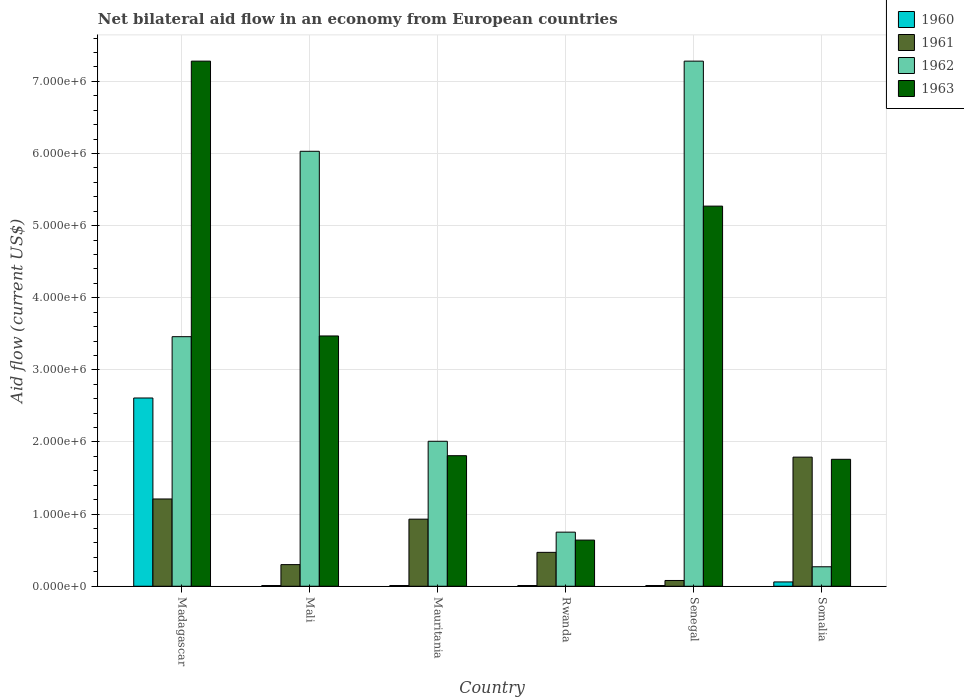How many different coloured bars are there?
Your answer should be very brief. 4. How many groups of bars are there?
Ensure brevity in your answer.  6. Are the number of bars on each tick of the X-axis equal?
Give a very brief answer. Yes. What is the label of the 2nd group of bars from the left?
Provide a succinct answer. Mali. In how many cases, is the number of bars for a given country not equal to the number of legend labels?
Your response must be concise. 0. What is the net bilateral aid flow in 1961 in Mauritania?
Your answer should be compact. 9.30e+05. Across all countries, what is the maximum net bilateral aid flow in 1961?
Ensure brevity in your answer.  1.79e+06. In which country was the net bilateral aid flow in 1963 maximum?
Give a very brief answer. Madagascar. In which country was the net bilateral aid flow in 1960 minimum?
Give a very brief answer. Mali. What is the total net bilateral aid flow in 1962 in the graph?
Make the answer very short. 1.98e+07. What is the difference between the net bilateral aid flow in 1961 in Senegal and that in Somalia?
Ensure brevity in your answer.  -1.71e+06. What is the difference between the net bilateral aid flow in 1960 in Madagascar and the net bilateral aid flow in 1962 in Rwanda?
Offer a very short reply. 1.86e+06. What is the average net bilateral aid flow in 1963 per country?
Your response must be concise. 3.37e+06. What is the difference between the net bilateral aid flow of/in 1962 and net bilateral aid flow of/in 1961 in Senegal?
Your response must be concise. 7.20e+06. What is the ratio of the net bilateral aid flow in 1963 in Senegal to that in Somalia?
Provide a short and direct response. 2.99. Is the net bilateral aid flow in 1962 in Madagascar less than that in Senegal?
Your answer should be compact. Yes. What is the difference between the highest and the second highest net bilateral aid flow in 1961?
Your answer should be very brief. 5.80e+05. What is the difference between the highest and the lowest net bilateral aid flow in 1961?
Your answer should be very brief. 1.71e+06. Is it the case that in every country, the sum of the net bilateral aid flow in 1963 and net bilateral aid flow in 1960 is greater than the sum of net bilateral aid flow in 1961 and net bilateral aid flow in 1962?
Ensure brevity in your answer.  Yes. What does the 3rd bar from the left in Senegal represents?
Offer a terse response. 1962. How many bars are there?
Your answer should be compact. 24. What is the difference between two consecutive major ticks on the Y-axis?
Your answer should be compact. 1.00e+06. Are the values on the major ticks of Y-axis written in scientific E-notation?
Offer a terse response. Yes. Does the graph contain any zero values?
Ensure brevity in your answer.  No. Does the graph contain grids?
Ensure brevity in your answer.  Yes. Where does the legend appear in the graph?
Ensure brevity in your answer.  Top right. How are the legend labels stacked?
Your response must be concise. Vertical. What is the title of the graph?
Offer a very short reply. Net bilateral aid flow in an economy from European countries. What is the label or title of the X-axis?
Your answer should be compact. Country. What is the Aid flow (current US$) in 1960 in Madagascar?
Keep it short and to the point. 2.61e+06. What is the Aid flow (current US$) in 1961 in Madagascar?
Offer a terse response. 1.21e+06. What is the Aid flow (current US$) of 1962 in Madagascar?
Ensure brevity in your answer.  3.46e+06. What is the Aid flow (current US$) in 1963 in Madagascar?
Provide a short and direct response. 7.28e+06. What is the Aid flow (current US$) in 1960 in Mali?
Offer a terse response. 10000. What is the Aid flow (current US$) of 1962 in Mali?
Keep it short and to the point. 6.03e+06. What is the Aid flow (current US$) of 1963 in Mali?
Provide a short and direct response. 3.47e+06. What is the Aid flow (current US$) of 1960 in Mauritania?
Your answer should be very brief. 10000. What is the Aid flow (current US$) in 1961 in Mauritania?
Your response must be concise. 9.30e+05. What is the Aid flow (current US$) of 1962 in Mauritania?
Provide a succinct answer. 2.01e+06. What is the Aid flow (current US$) in 1963 in Mauritania?
Keep it short and to the point. 1.81e+06. What is the Aid flow (current US$) of 1961 in Rwanda?
Provide a short and direct response. 4.70e+05. What is the Aid flow (current US$) in 1962 in Rwanda?
Your answer should be very brief. 7.50e+05. What is the Aid flow (current US$) of 1963 in Rwanda?
Ensure brevity in your answer.  6.40e+05. What is the Aid flow (current US$) in 1960 in Senegal?
Keep it short and to the point. 10000. What is the Aid flow (current US$) in 1961 in Senegal?
Your answer should be very brief. 8.00e+04. What is the Aid flow (current US$) of 1962 in Senegal?
Offer a terse response. 7.28e+06. What is the Aid flow (current US$) in 1963 in Senegal?
Your answer should be compact. 5.27e+06. What is the Aid flow (current US$) of 1960 in Somalia?
Provide a succinct answer. 6.00e+04. What is the Aid flow (current US$) in 1961 in Somalia?
Ensure brevity in your answer.  1.79e+06. What is the Aid flow (current US$) of 1963 in Somalia?
Offer a very short reply. 1.76e+06. Across all countries, what is the maximum Aid flow (current US$) in 1960?
Your response must be concise. 2.61e+06. Across all countries, what is the maximum Aid flow (current US$) in 1961?
Provide a short and direct response. 1.79e+06. Across all countries, what is the maximum Aid flow (current US$) in 1962?
Provide a succinct answer. 7.28e+06. Across all countries, what is the maximum Aid flow (current US$) in 1963?
Provide a succinct answer. 7.28e+06. Across all countries, what is the minimum Aid flow (current US$) of 1961?
Give a very brief answer. 8.00e+04. Across all countries, what is the minimum Aid flow (current US$) of 1962?
Provide a succinct answer. 2.70e+05. Across all countries, what is the minimum Aid flow (current US$) in 1963?
Give a very brief answer. 6.40e+05. What is the total Aid flow (current US$) of 1960 in the graph?
Your answer should be very brief. 2.71e+06. What is the total Aid flow (current US$) in 1961 in the graph?
Your response must be concise. 4.78e+06. What is the total Aid flow (current US$) of 1962 in the graph?
Your answer should be compact. 1.98e+07. What is the total Aid flow (current US$) in 1963 in the graph?
Give a very brief answer. 2.02e+07. What is the difference between the Aid flow (current US$) in 1960 in Madagascar and that in Mali?
Offer a very short reply. 2.60e+06. What is the difference between the Aid flow (current US$) of 1961 in Madagascar and that in Mali?
Keep it short and to the point. 9.10e+05. What is the difference between the Aid flow (current US$) of 1962 in Madagascar and that in Mali?
Provide a short and direct response. -2.57e+06. What is the difference between the Aid flow (current US$) in 1963 in Madagascar and that in Mali?
Give a very brief answer. 3.81e+06. What is the difference between the Aid flow (current US$) of 1960 in Madagascar and that in Mauritania?
Your answer should be very brief. 2.60e+06. What is the difference between the Aid flow (current US$) of 1962 in Madagascar and that in Mauritania?
Ensure brevity in your answer.  1.45e+06. What is the difference between the Aid flow (current US$) in 1963 in Madagascar and that in Mauritania?
Keep it short and to the point. 5.47e+06. What is the difference between the Aid flow (current US$) in 1960 in Madagascar and that in Rwanda?
Your answer should be compact. 2.60e+06. What is the difference between the Aid flow (current US$) of 1961 in Madagascar and that in Rwanda?
Offer a very short reply. 7.40e+05. What is the difference between the Aid flow (current US$) in 1962 in Madagascar and that in Rwanda?
Provide a short and direct response. 2.71e+06. What is the difference between the Aid flow (current US$) in 1963 in Madagascar and that in Rwanda?
Keep it short and to the point. 6.64e+06. What is the difference between the Aid flow (current US$) in 1960 in Madagascar and that in Senegal?
Offer a terse response. 2.60e+06. What is the difference between the Aid flow (current US$) of 1961 in Madagascar and that in Senegal?
Provide a succinct answer. 1.13e+06. What is the difference between the Aid flow (current US$) in 1962 in Madagascar and that in Senegal?
Offer a very short reply. -3.82e+06. What is the difference between the Aid flow (current US$) of 1963 in Madagascar and that in Senegal?
Keep it short and to the point. 2.01e+06. What is the difference between the Aid flow (current US$) in 1960 in Madagascar and that in Somalia?
Provide a succinct answer. 2.55e+06. What is the difference between the Aid flow (current US$) of 1961 in Madagascar and that in Somalia?
Your answer should be very brief. -5.80e+05. What is the difference between the Aid flow (current US$) in 1962 in Madagascar and that in Somalia?
Ensure brevity in your answer.  3.19e+06. What is the difference between the Aid flow (current US$) of 1963 in Madagascar and that in Somalia?
Make the answer very short. 5.52e+06. What is the difference between the Aid flow (current US$) in 1961 in Mali and that in Mauritania?
Offer a terse response. -6.30e+05. What is the difference between the Aid flow (current US$) of 1962 in Mali and that in Mauritania?
Keep it short and to the point. 4.02e+06. What is the difference between the Aid flow (current US$) in 1963 in Mali and that in Mauritania?
Ensure brevity in your answer.  1.66e+06. What is the difference between the Aid flow (current US$) in 1960 in Mali and that in Rwanda?
Ensure brevity in your answer.  0. What is the difference between the Aid flow (current US$) of 1962 in Mali and that in Rwanda?
Your response must be concise. 5.28e+06. What is the difference between the Aid flow (current US$) in 1963 in Mali and that in Rwanda?
Your answer should be compact. 2.83e+06. What is the difference between the Aid flow (current US$) of 1960 in Mali and that in Senegal?
Your answer should be very brief. 0. What is the difference between the Aid flow (current US$) in 1961 in Mali and that in Senegal?
Offer a very short reply. 2.20e+05. What is the difference between the Aid flow (current US$) of 1962 in Mali and that in Senegal?
Make the answer very short. -1.25e+06. What is the difference between the Aid flow (current US$) of 1963 in Mali and that in Senegal?
Make the answer very short. -1.80e+06. What is the difference between the Aid flow (current US$) of 1961 in Mali and that in Somalia?
Your answer should be very brief. -1.49e+06. What is the difference between the Aid flow (current US$) of 1962 in Mali and that in Somalia?
Ensure brevity in your answer.  5.76e+06. What is the difference between the Aid flow (current US$) of 1963 in Mali and that in Somalia?
Ensure brevity in your answer.  1.71e+06. What is the difference between the Aid flow (current US$) in 1960 in Mauritania and that in Rwanda?
Your answer should be very brief. 0. What is the difference between the Aid flow (current US$) of 1961 in Mauritania and that in Rwanda?
Offer a very short reply. 4.60e+05. What is the difference between the Aid flow (current US$) in 1962 in Mauritania and that in Rwanda?
Give a very brief answer. 1.26e+06. What is the difference between the Aid flow (current US$) of 1963 in Mauritania and that in Rwanda?
Offer a very short reply. 1.17e+06. What is the difference between the Aid flow (current US$) in 1961 in Mauritania and that in Senegal?
Your answer should be very brief. 8.50e+05. What is the difference between the Aid flow (current US$) in 1962 in Mauritania and that in Senegal?
Offer a very short reply. -5.27e+06. What is the difference between the Aid flow (current US$) of 1963 in Mauritania and that in Senegal?
Your answer should be compact. -3.46e+06. What is the difference between the Aid flow (current US$) of 1961 in Mauritania and that in Somalia?
Provide a succinct answer. -8.60e+05. What is the difference between the Aid flow (current US$) in 1962 in Mauritania and that in Somalia?
Give a very brief answer. 1.74e+06. What is the difference between the Aid flow (current US$) of 1963 in Mauritania and that in Somalia?
Provide a succinct answer. 5.00e+04. What is the difference between the Aid flow (current US$) in 1962 in Rwanda and that in Senegal?
Your answer should be compact. -6.53e+06. What is the difference between the Aid flow (current US$) of 1963 in Rwanda and that in Senegal?
Your response must be concise. -4.63e+06. What is the difference between the Aid flow (current US$) of 1960 in Rwanda and that in Somalia?
Provide a short and direct response. -5.00e+04. What is the difference between the Aid flow (current US$) in 1961 in Rwanda and that in Somalia?
Provide a short and direct response. -1.32e+06. What is the difference between the Aid flow (current US$) in 1963 in Rwanda and that in Somalia?
Give a very brief answer. -1.12e+06. What is the difference between the Aid flow (current US$) of 1960 in Senegal and that in Somalia?
Your answer should be very brief. -5.00e+04. What is the difference between the Aid flow (current US$) in 1961 in Senegal and that in Somalia?
Make the answer very short. -1.71e+06. What is the difference between the Aid flow (current US$) of 1962 in Senegal and that in Somalia?
Give a very brief answer. 7.01e+06. What is the difference between the Aid flow (current US$) in 1963 in Senegal and that in Somalia?
Offer a terse response. 3.51e+06. What is the difference between the Aid flow (current US$) of 1960 in Madagascar and the Aid flow (current US$) of 1961 in Mali?
Offer a terse response. 2.31e+06. What is the difference between the Aid flow (current US$) in 1960 in Madagascar and the Aid flow (current US$) in 1962 in Mali?
Provide a succinct answer. -3.42e+06. What is the difference between the Aid flow (current US$) of 1960 in Madagascar and the Aid flow (current US$) of 1963 in Mali?
Make the answer very short. -8.60e+05. What is the difference between the Aid flow (current US$) of 1961 in Madagascar and the Aid flow (current US$) of 1962 in Mali?
Give a very brief answer. -4.82e+06. What is the difference between the Aid flow (current US$) in 1961 in Madagascar and the Aid flow (current US$) in 1963 in Mali?
Your answer should be compact. -2.26e+06. What is the difference between the Aid flow (current US$) of 1960 in Madagascar and the Aid flow (current US$) of 1961 in Mauritania?
Provide a short and direct response. 1.68e+06. What is the difference between the Aid flow (current US$) in 1961 in Madagascar and the Aid flow (current US$) in 1962 in Mauritania?
Your answer should be very brief. -8.00e+05. What is the difference between the Aid flow (current US$) of 1961 in Madagascar and the Aid flow (current US$) of 1963 in Mauritania?
Your response must be concise. -6.00e+05. What is the difference between the Aid flow (current US$) of 1962 in Madagascar and the Aid flow (current US$) of 1963 in Mauritania?
Provide a short and direct response. 1.65e+06. What is the difference between the Aid flow (current US$) of 1960 in Madagascar and the Aid flow (current US$) of 1961 in Rwanda?
Provide a succinct answer. 2.14e+06. What is the difference between the Aid flow (current US$) of 1960 in Madagascar and the Aid flow (current US$) of 1962 in Rwanda?
Make the answer very short. 1.86e+06. What is the difference between the Aid flow (current US$) in 1960 in Madagascar and the Aid flow (current US$) in 1963 in Rwanda?
Provide a succinct answer. 1.97e+06. What is the difference between the Aid flow (current US$) of 1961 in Madagascar and the Aid flow (current US$) of 1963 in Rwanda?
Ensure brevity in your answer.  5.70e+05. What is the difference between the Aid flow (current US$) in 1962 in Madagascar and the Aid flow (current US$) in 1963 in Rwanda?
Your answer should be compact. 2.82e+06. What is the difference between the Aid flow (current US$) of 1960 in Madagascar and the Aid flow (current US$) of 1961 in Senegal?
Keep it short and to the point. 2.53e+06. What is the difference between the Aid flow (current US$) in 1960 in Madagascar and the Aid flow (current US$) in 1962 in Senegal?
Your response must be concise. -4.67e+06. What is the difference between the Aid flow (current US$) in 1960 in Madagascar and the Aid flow (current US$) in 1963 in Senegal?
Offer a terse response. -2.66e+06. What is the difference between the Aid flow (current US$) of 1961 in Madagascar and the Aid flow (current US$) of 1962 in Senegal?
Your answer should be compact. -6.07e+06. What is the difference between the Aid flow (current US$) of 1961 in Madagascar and the Aid flow (current US$) of 1963 in Senegal?
Keep it short and to the point. -4.06e+06. What is the difference between the Aid flow (current US$) of 1962 in Madagascar and the Aid flow (current US$) of 1963 in Senegal?
Make the answer very short. -1.81e+06. What is the difference between the Aid flow (current US$) of 1960 in Madagascar and the Aid flow (current US$) of 1961 in Somalia?
Provide a short and direct response. 8.20e+05. What is the difference between the Aid flow (current US$) of 1960 in Madagascar and the Aid flow (current US$) of 1962 in Somalia?
Provide a succinct answer. 2.34e+06. What is the difference between the Aid flow (current US$) of 1960 in Madagascar and the Aid flow (current US$) of 1963 in Somalia?
Your answer should be very brief. 8.50e+05. What is the difference between the Aid flow (current US$) in 1961 in Madagascar and the Aid flow (current US$) in 1962 in Somalia?
Make the answer very short. 9.40e+05. What is the difference between the Aid flow (current US$) of 1961 in Madagascar and the Aid flow (current US$) of 1963 in Somalia?
Offer a terse response. -5.50e+05. What is the difference between the Aid flow (current US$) in 1962 in Madagascar and the Aid flow (current US$) in 1963 in Somalia?
Your answer should be compact. 1.70e+06. What is the difference between the Aid flow (current US$) in 1960 in Mali and the Aid flow (current US$) in 1961 in Mauritania?
Your answer should be compact. -9.20e+05. What is the difference between the Aid flow (current US$) in 1960 in Mali and the Aid flow (current US$) in 1962 in Mauritania?
Offer a very short reply. -2.00e+06. What is the difference between the Aid flow (current US$) in 1960 in Mali and the Aid flow (current US$) in 1963 in Mauritania?
Provide a short and direct response. -1.80e+06. What is the difference between the Aid flow (current US$) of 1961 in Mali and the Aid flow (current US$) of 1962 in Mauritania?
Offer a very short reply. -1.71e+06. What is the difference between the Aid flow (current US$) of 1961 in Mali and the Aid flow (current US$) of 1963 in Mauritania?
Give a very brief answer. -1.51e+06. What is the difference between the Aid flow (current US$) in 1962 in Mali and the Aid flow (current US$) in 1963 in Mauritania?
Offer a very short reply. 4.22e+06. What is the difference between the Aid flow (current US$) of 1960 in Mali and the Aid flow (current US$) of 1961 in Rwanda?
Offer a terse response. -4.60e+05. What is the difference between the Aid flow (current US$) of 1960 in Mali and the Aid flow (current US$) of 1962 in Rwanda?
Provide a short and direct response. -7.40e+05. What is the difference between the Aid flow (current US$) in 1960 in Mali and the Aid flow (current US$) in 1963 in Rwanda?
Keep it short and to the point. -6.30e+05. What is the difference between the Aid flow (current US$) in 1961 in Mali and the Aid flow (current US$) in 1962 in Rwanda?
Make the answer very short. -4.50e+05. What is the difference between the Aid flow (current US$) of 1961 in Mali and the Aid flow (current US$) of 1963 in Rwanda?
Offer a very short reply. -3.40e+05. What is the difference between the Aid flow (current US$) of 1962 in Mali and the Aid flow (current US$) of 1963 in Rwanda?
Offer a terse response. 5.39e+06. What is the difference between the Aid flow (current US$) in 1960 in Mali and the Aid flow (current US$) in 1962 in Senegal?
Ensure brevity in your answer.  -7.27e+06. What is the difference between the Aid flow (current US$) of 1960 in Mali and the Aid flow (current US$) of 1963 in Senegal?
Your answer should be compact. -5.26e+06. What is the difference between the Aid flow (current US$) in 1961 in Mali and the Aid flow (current US$) in 1962 in Senegal?
Give a very brief answer. -6.98e+06. What is the difference between the Aid flow (current US$) of 1961 in Mali and the Aid flow (current US$) of 1963 in Senegal?
Offer a terse response. -4.97e+06. What is the difference between the Aid flow (current US$) of 1962 in Mali and the Aid flow (current US$) of 1963 in Senegal?
Provide a succinct answer. 7.60e+05. What is the difference between the Aid flow (current US$) of 1960 in Mali and the Aid flow (current US$) of 1961 in Somalia?
Provide a short and direct response. -1.78e+06. What is the difference between the Aid flow (current US$) of 1960 in Mali and the Aid flow (current US$) of 1962 in Somalia?
Your answer should be compact. -2.60e+05. What is the difference between the Aid flow (current US$) of 1960 in Mali and the Aid flow (current US$) of 1963 in Somalia?
Offer a very short reply. -1.75e+06. What is the difference between the Aid flow (current US$) in 1961 in Mali and the Aid flow (current US$) in 1963 in Somalia?
Provide a short and direct response. -1.46e+06. What is the difference between the Aid flow (current US$) in 1962 in Mali and the Aid flow (current US$) in 1963 in Somalia?
Provide a short and direct response. 4.27e+06. What is the difference between the Aid flow (current US$) in 1960 in Mauritania and the Aid flow (current US$) in 1961 in Rwanda?
Your answer should be very brief. -4.60e+05. What is the difference between the Aid flow (current US$) of 1960 in Mauritania and the Aid flow (current US$) of 1962 in Rwanda?
Give a very brief answer. -7.40e+05. What is the difference between the Aid flow (current US$) in 1960 in Mauritania and the Aid flow (current US$) in 1963 in Rwanda?
Your response must be concise. -6.30e+05. What is the difference between the Aid flow (current US$) of 1962 in Mauritania and the Aid flow (current US$) of 1963 in Rwanda?
Offer a terse response. 1.37e+06. What is the difference between the Aid flow (current US$) of 1960 in Mauritania and the Aid flow (current US$) of 1962 in Senegal?
Your answer should be very brief. -7.27e+06. What is the difference between the Aid flow (current US$) in 1960 in Mauritania and the Aid flow (current US$) in 1963 in Senegal?
Provide a short and direct response. -5.26e+06. What is the difference between the Aid flow (current US$) of 1961 in Mauritania and the Aid flow (current US$) of 1962 in Senegal?
Make the answer very short. -6.35e+06. What is the difference between the Aid flow (current US$) of 1961 in Mauritania and the Aid flow (current US$) of 1963 in Senegal?
Your answer should be compact. -4.34e+06. What is the difference between the Aid flow (current US$) in 1962 in Mauritania and the Aid flow (current US$) in 1963 in Senegal?
Offer a very short reply. -3.26e+06. What is the difference between the Aid flow (current US$) of 1960 in Mauritania and the Aid flow (current US$) of 1961 in Somalia?
Your response must be concise. -1.78e+06. What is the difference between the Aid flow (current US$) in 1960 in Mauritania and the Aid flow (current US$) in 1963 in Somalia?
Keep it short and to the point. -1.75e+06. What is the difference between the Aid flow (current US$) in 1961 in Mauritania and the Aid flow (current US$) in 1962 in Somalia?
Offer a terse response. 6.60e+05. What is the difference between the Aid flow (current US$) in 1961 in Mauritania and the Aid flow (current US$) in 1963 in Somalia?
Offer a very short reply. -8.30e+05. What is the difference between the Aid flow (current US$) of 1960 in Rwanda and the Aid flow (current US$) of 1961 in Senegal?
Offer a very short reply. -7.00e+04. What is the difference between the Aid flow (current US$) of 1960 in Rwanda and the Aid flow (current US$) of 1962 in Senegal?
Your answer should be very brief. -7.27e+06. What is the difference between the Aid flow (current US$) of 1960 in Rwanda and the Aid flow (current US$) of 1963 in Senegal?
Give a very brief answer. -5.26e+06. What is the difference between the Aid flow (current US$) in 1961 in Rwanda and the Aid flow (current US$) in 1962 in Senegal?
Ensure brevity in your answer.  -6.81e+06. What is the difference between the Aid flow (current US$) in 1961 in Rwanda and the Aid flow (current US$) in 1963 in Senegal?
Your response must be concise. -4.80e+06. What is the difference between the Aid flow (current US$) in 1962 in Rwanda and the Aid flow (current US$) in 1963 in Senegal?
Provide a succinct answer. -4.52e+06. What is the difference between the Aid flow (current US$) of 1960 in Rwanda and the Aid flow (current US$) of 1961 in Somalia?
Offer a very short reply. -1.78e+06. What is the difference between the Aid flow (current US$) in 1960 in Rwanda and the Aid flow (current US$) in 1962 in Somalia?
Offer a terse response. -2.60e+05. What is the difference between the Aid flow (current US$) in 1960 in Rwanda and the Aid flow (current US$) in 1963 in Somalia?
Your response must be concise. -1.75e+06. What is the difference between the Aid flow (current US$) of 1961 in Rwanda and the Aid flow (current US$) of 1963 in Somalia?
Keep it short and to the point. -1.29e+06. What is the difference between the Aid flow (current US$) in 1962 in Rwanda and the Aid flow (current US$) in 1963 in Somalia?
Offer a terse response. -1.01e+06. What is the difference between the Aid flow (current US$) of 1960 in Senegal and the Aid flow (current US$) of 1961 in Somalia?
Keep it short and to the point. -1.78e+06. What is the difference between the Aid flow (current US$) of 1960 in Senegal and the Aid flow (current US$) of 1962 in Somalia?
Your answer should be compact. -2.60e+05. What is the difference between the Aid flow (current US$) of 1960 in Senegal and the Aid flow (current US$) of 1963 in Somalia?
Make the answer very short. -1.75e+06. What is the difference between the Aid flow (current US$) in 1961 in Senegal and the Aid flow (current US$) in 1962 in Somalia?
Make the answer very short. -1.90e+05. What is the difference between the Aid flow (current US$) of 1961 in Senegal and the Aid flow (current US$) of 1963 in Somalia?
Make the answer very short. -1.68e+06. What is the difference between the Aid flow (current US$) in 1962 in Senegal and the Aid flow (current US$) in 1963 in Somalia?
Make the answer very short. 5.52e+06. What is the average Aid flow (current US$) in 1960 per country?
Offer a very short reply. 4.52e+05. What is the average Aid flow (current US$) of 1961 per country?
Your answer should be very brief. 7.97e+05. What is the average Aid flow (current US$) of 1962 per country?
Your answer should be very brief. 3.30e+06. What is the average Aid flow (current US$) of 1963 per country?
Keep it short and to the point. 3.37e+06. What is the difference between the Aid flow (current US$) of 1960 and Aid flow (current US$) of 1961 in Madagascar?
Make the answer very short. 1.40e+06. What is the difference between the Aid flow (current US$) in 1960 and Aid flow (current US$) in 1962 in Madagascar?
Provide a short and direct response. -8.50e+05. What is the difference between the Aid flow (current US$) of 1960 and Aid flow (current US$) of 1963 in Madagascar?
Provide a short and direct response. -4.67e+06. What is the difference between the Aid flow (current US$) of 1961 and Aid flow (current US$) of 1962 in Madagascar?
Provide a succinct answer. -2.25e+06. What is the difference between the Aid flow (current US$) of 1961 and Aid flow (current US$) of 1963 in Madagascar?
Keep it short and to the point. -6.07e+06. What is the difference between the Aid flow (current US$) of 1962 and Aid flow (current US$) of 1963 in Madagascar?
Provide a short and direct response. -3.82e+06. What is the difference between the Aid flow (current US$) of 1960 and Aid flow (current US$) of 1961 in Mali?
Offer a very short reply. -2.90e+05. What is the difference between the Aid flow (current US$) in 1960 and Aid flow (current US$) in 1962 in Mali?
Offer a very short reply. -6.02e+06. What is the difference between the Aid flow (current US$) of 1960 and Aid flow (current US$) of 1963 in Mali?
Give a very brief answer. -3.46e+06. What is the difference between the Aid flow (current US$) in 1961 and Aid flow (current US$) in 1962 in Mali?
Provide a short and direct response. -5.73e+06. What is the difference between the Aid flow (current US$) of 1961 and Aid flow (current US$) of 1963 in Mali?
Your answer should be compact. -3.17e+06. What is the difference between the Aid flow (current US$) of 1962 and Aid flow (current US$) of 1963 in Mali?
Your answer should be compact. 2.56e+06. What is the difference between the Aid flow (current US$) of 1960 and Aid flow (current US$) of 1961 in Mauritania?
Offer a terse response. -9.20e+05. What is the difference between the Aid flow (current US$) in 1960 and Aid flow (current US$) in 1963 in Mauritania?
Provide a short and direct response. -1.80e+06. What is the difference between the Aid flow (current US$) of 1961 and Aid flow (current US$) of 1962 in Mauritania?
Ensure brevity in your answer.  -1.08e+06. What is the difference between the Aid flow (current US$) of 1961 and Aid flow (current US$) of 1963 in Mauritania?
Provide a short and direct response. -8.80e+05. What is the difference between the Aid flow (current US$) of 1960 and Aid flow (current US$) of 1961 in Rwanda?
Offer a very short reply. -4.60e+05. What is the difference between the Aid flow (current US$) in 1960 and Aid flow (current US$) in 1962 in Rwanda?
Make the answer very short. -7.40e+05. What is the difference between the Aid flow (current US$) in 1960 and Aid flow (current US$) in 1963 in Rwanda?
Your response must be concise. -6.30e+05. What is the difference between the Aid flow (current US$) of 1961 and Aid flow (current US$) of 1962 in Rwanda?
Your response must be concise. -2.80e+05. What is the difference between the Aid flow (current US$) in 1962 and Aid flow (current US$) in 1963 in Rwanda?
Ensure brevity in your answer.  1.10e+05. What is the difference between the Aid flow (current US$) in 1960 and Aid flow (current US$) in 1961 in Senegal?
Offer a terse response. -7.00e+04. What is the difference between the Aid flow (current US$) in 1960 and Aid flow (current US$) in 1962 in Senegal?
Your response must be concise. -7.27e+06. What is the difference between the Aid flow (current US$) of 1960 and Aid flow (current US$) of 1963 in Senegal?
Give a very brief answer. -5.26e+06. What is the difference between the Aid flow (current US$) of 1961 and Aid flow (current US$) of 1962 in Senegal?
Your response must be concise. -7.20e+06. What is the difference between the Aid flow (current US$) of 1961 and Aid flow (current US$) of 1963 in Senegal?
Your response must be concise. -5.19e+06. What is the difference between the Aid flow (current US$) in 1962 and Aid flow (current US$) in 1963 in Senegal?
Keep it short and to the point. 2.01e+06. What is the difference between the Aid flow (current US$) of 1960 and Aid flow (current US$) of 1961 in Somalia?
Provide a short and direct response. -1.73e+06. What is the difference between the Aid flow (current US$) in 1960 and Aid flow (current US$) in 1963 in Somalia?
Provide a short and direct response. -1.70e+06. What is the difference between the Aid flow (current US$) in 1961 and Aid flow (current US$) in 1962 in Somalia?
Make the answer very short. 1.52e+06. What is the difference between the Aid flow (current US$) in 1961 and Aid flow (current US$) in 1963 in Somalia?
Keep it short and to the point. 3.00e+04. What is the difference between the Aid flow (current US$) in 1962 and Aid flow (current US$) in 1963 in Somalia?
Provide a succinct answer. -1.49e+06. What is the ratio of the Aid flow (current US$) in 1960 in Madagascar to that in Mali?
Offer a very short reply. 261. What is the ratio of the Aid flow (current US$) of 1961 in Madagascar to that in Mali?
Offer a terse response. 4.03. What is the ratio of the Aid flow (current US$) in 1962 in Madagascar to that in Mali?
Make the answer very short. 0.57. What is the ratio of the Aid flow (current US$) in 1963 in Madagascar to that in Mali?
Your answer should be very brief. 2.1. What is the ratio of the Aid flow (current US$) in 1960 in Madagascar to that in Mauritania?
Give a very brief answer. 261. What is the ratio of the Aid flow (current US$) in 1961 in Madagascar to that in Mauritania?
Make the answer very short. 1.3. What is the ratio of the Aid flow (current US$) in 1962 in Madagascar to that in Mauritania?
Provide a succinct answer. 1.72. What is the ratio of the Aid flow (current US$) of 1963 in Madagascar to that in Mauritania?
Keep it short and to the point. 4.02. What is the ratio of the Aid flow (current US$) in 1960 in Madagascar to that in Rwanda?
Make the answer very short. 261. What is the ratio of the Aid flow (current US$) of 1961 in Madagascar to that in Rwanda?
Keep it short and to the point. 2.57. What is the ratio of the Aid flow (current US$) of 1962 in Madagascar to that in Rwanda?
Make the answer very short. 4.61. What is the ratio of the Aid flow (current US$) in 1963 in Madagascar to that in Rwanda?
Provide a succinct answer. 11.38. What is the ratio of the Aid flow (current US$) in 1960 in Madagascar to that in Senegal?
Offer a very short reply. 261. What is the ratio of the Aid flow (current US$) in 1961 in Madagascar to that in Senegal?
Keep it short and to the point. 15.12. What is the ratio of the Aid flow (current US$) of 1962 in Madagascar to that in Senegal?
Your answer should be very brief. 0.48. What is the ratio of the Aid flow (current US$) in 1963 in Madagascar to that in Senegal?
Ensure brevity in your answer.  1.38. What is the ratio of the Aid flow (current US$) in 1960 in Madagascar to that in Somalia?
Give a very brief answer. 43.5. What is the ratio of the Aid flow (current US$) in 1961 in Madagascar to that in Somalia?
Ensure brevity in your answer.  0.68. What is the ratio of the Aid flow (current US$) in 1962 in Madagascar to that in Somalia?
Provide a short and direct response. 12.81. What is the ratio of the Aid flow (current US$) of 1963 in Madagascar to that in Somalia?
Offer a very short reply. 4.14. What is the ratio of the Aid flow (current US$) of 1961 in Mali to that in Mauritania?
Ensure brevity in your answer.  0.32. What is the ratio of the Aid flow (current US$) of 1963 in Mali to that in Mauritania?
Your response must be concise. 1.92. What is the ratio of the Aid flow (current US$) in 1960 in Mali to that in Rwanda?
Provide a succinct answer. 1. What is the ratio of the Aid flow (current US$) in 1961 in Mali to that in Rwanda?
Keep it short and to the point. 0.64. What is the ratio of the Aid flow (current US$) of 1962 in Mali to that in Rwanda?
Your response must be concise. 8.04. What is the ratio of the Aid flow (current US$) in 1963 in Mali to that in Rwanda?
Give a very brief answer. 5.42. What is the ratio of the Aid flow (current US$) in 1961 in Mali to that in Senegal?
Offer a very short reply. 3.75. What is the ratio of the Aid flow (current US$) in 1962 in Mali to that in Senegal?
Provide a short and direct response. 0.83. What is the ratio of the Aid flow (current US$) in 1963 in Mali to that in Senegal?
Ensure brevity in your answer.  0.66. What is the ratio of the Aid flow (current US$) of 1961 in Mali to that in Somalia?
Offer a very short reply. 0.17. What is the ratio of the Aid flow (current US$) of 1962 in Mali to that in Somalia?
Your answer should be very brief. 22.33. What is the ratio of the Aid flow (current US$) in 1963 in Mali to that in Somalia?
Keep it short and to the point. 1.97. What is the ratio of the Aid flow (current US$) of 1960 in Mauritania to that in Rwanda?
Your answer should be compact. 1. What is the ratio of the Aid flow (current US$) in 1961 in Mauritania to that in Rwanda?
Your answer should be compact. 1.98. What is the ratio of the Aid flow (current US$) of 1962 in Mauritania to that in Rwanda?
Your answer should be very brief. 2.68. What is the ratio of the Aid flow (current US$) in 1963 in Mauritania to that in Rwanda?
Offer a terse response. 2.83. What is the ratio of the Aid flow (current US$) of 1960 in Mauritania to that in Senegal?
Your answer should be very brief. 1. What is the ratio of the Aid flow (current US$) of 1961 in Mauritania to that in Senegal?
Keep it short and to the point. 11.62. What is the ratio of the Aid flow (current US$) in 1962 in Mauritania to that in Senegal?
Keep it short and to the point. 0.28. What is the ratio of the Aid flow (current US$) of 1963 in Mauritania to that in Senegal?
Keep it short and to the point. 0.34. What is the ratio of the Aid flow (current US$) of 1961 in Mauritania to that in Somalia?
Keep it short and to the point. 0.52. What is the ratio of the Aid flow (current US$) in 1962 in Mauritania to that in Somalia?
Give a very brief answer. 7.44. What is the ratio of the Aid flow (current US$) of 1963 in Mauritania to that in Somalia?
Ensure brevity in your answer.  1.03. What is the ratio of the Aid flow (current US$) in 1960 in Rwanda to that in Senegal?
Your answer should be compact. 1. What is the ratio of the Aid flow (current US$) of 1961 in Rwanda to that in Senegal?
Give a very brief answer. 5.88. What is the ratio of the Aid flow (current US$) of 1962 in Rwanda to that in Senegal?
Ensure brevity in your answer.  0.1. What is the ratio of the Aid flow (current US$) of 1963 in Rwanda to that in Senegal?
Offer a very short reply. 0.12. What is the ratio of the Aid flow (current US$) of 1960 in Rwanda to that in Somalia?
Offer a very short reply. 0.17. What is the ratio of the Aid flow (current US$) in 1961 in Rwanda to that in Somalia?
Provide a succinct answer. 0.26. What is the ratio of the Aid flow (current US$) in 1962 in Rwanda to that in Somalia?
Your answer should be very brief. 2.78. What is the ratio of the Aid flow (current US$) in 1963 in Rwanda to that in Somalia?
Your response must be concise. 0.36. What is the ratio of the Aid flow (current US$) of 1960 in Senegal to that in Somalia?
Offer a very short reply. 0.17. What is the ratio of the Aid flow (current US$) of 1961 in Senegal to that in Somalia?
Offer a very short reply. 0.04. What is the ratio of the Aid flow (current US$) in 1962 in Senegal to that in Somalia?
Offer a very short reply. 26.96. What is the ratio of the Aid flow (current US$) in 1963 in Senegal to that in Somalia?
Your response must be concise. 2.99. What is the difference between the highest and the second highest Aid flow (current US$) in 1960?
Ensure brevity in your answer.  2.55e+06. What is the difference between the highest and the second highest Aid flow (current US$) of 1961?
Your answer should be compact. 5.80e+05. What is the difference between the highest and the second highest Aid flow (current US$) in 1962?
Your response must be concise. 1.25e+06. What is the difference between the highest and the second highest Aid flow (current US$) in 1963?
Make the answer very short. 2.01e+06. What is the difference between the highest and the lowest Aid flow (current US$) of 1960?
Ensure brevity in your answer.  2.60e+06. What is the difference between the highest and the lowest Aid flow (current US$) of 1961?
Offer a terse response. 1.71e+06. What is the difference between the highest and the lowest Aid flow (current US$) in 1962?
Your answer should be compact. 7.01e+06. What is the difference between the highest and the lowest Aid flow (current US$) in 1963?
Your response must be concise. 6.64e+06. 